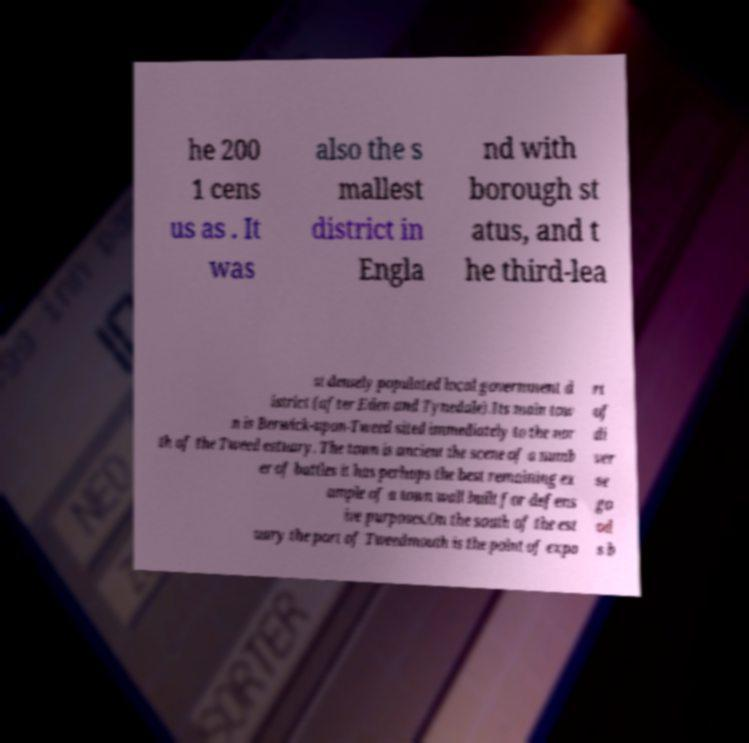For documentation purposes, I need the text within this image transcribed. Could you provide that? he 200 1 cens us as . It was also the s mallest district in Engla nd with borough st atus, and t he third-lea st densely populated local government d istrict (after Eden and Tynedale).Its main tow n is Berwick-upon-Tweed sited immediately to the nor th of the Tweed estuary. The town is ancient the scene of a numb er of battles it has perhaps the best remaining ex ample of a town wall built for defens ive purposes.On the south of the est uary the port of Tweedmouth is the point of expo rt of di ver se go od s b 